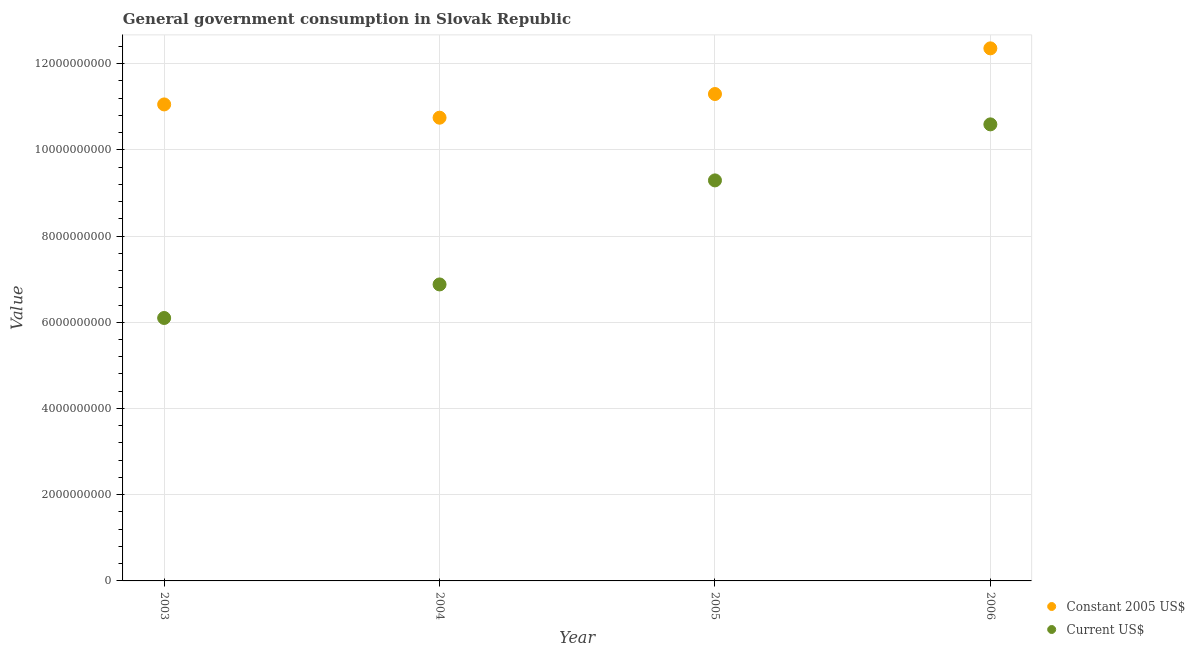Is the number of dotlines equal to the number of legend labels?
Your answer should be compact. Yes. What is the value consumed in constant 2005 us$ in 2005?
Offer a terse response. 1.13e+1. Across all years, what is the maximum value consumed in constant 2005 us$?
Give a very brief answer. 1.24e+1. Across all years, what is the minimum value consumed in current us$?
Your answer should be very brief. 6.10e+09. In which year was the value consumed in current us$ maximum?
Your answer should be very brief. 2006. What is the total value consumed in constant 2005 us$ in the graph?
Provide a succinct answer. 4.54e+1. What is the difference between the value consumed in current us$ in 2003 and that in 2006?
Provide a succinct answer. -4.49e+09. What is the difference between the value consumed in constant 2005 us$ in 2006 and the value consumed in current us$ in 2004?
Make the answer very short. 5.48e+09. What is the average value consumed in constant 2005 us$ per year?
Give a very brief answer. 1.14e+1. In the year 2005, what is the difference between the value consumed in current us$ and value consumed in constant 2005 us$?
Provide a short and direct response. -2.00e+09. What is the ratio of the value consumed in current us$ in 2004 to that in 2005?
Give a very brief answer. 0.74. Is the value consumed in current us$ in 2003 less than that in 2004?
Provide a short and direct response. Yes. Is the difference between the value consumed in current us$ in 2004 and 2005 greater than the difference between the value consumed in constant 2005 us$ in 2004 and 2005?
Your answer should be compact. No. What is the difference between the highest and the second highest value consumed in constant 2005 us$?
Offer a very short reply. 1.06e+09. What is the difference between the highest and the lowest value consumed in constant 2005 us$?
Offer a terse response. 1.61e+09. Is the value consumed in constant 2005 us$ strictly greater than the value consumed in current us$ over the years?
Offer a very short reply. Yes. Is the value consumed in constant 2005 us$ strictly less than the value consumed in current us$ over the years?
Give a very brief answer. No. How many dotlines are there?
Keep it short and to the point. 2. What is the difference between two consecutive major ticks on the Y-axis?
Give a very brief answer. 2.00e+09. Are the values on the major ticks of Y-axis written in scientific E-notation?
Provide a succinct answer. No. Does the graph contain grids?
Your answer should be very brief. Yes. Where does the legend appear in the graph?
Provide a short and direct response. Bottom right. How are the legend labels stacked?
Keep it short and to the point. Vertical. What is the title of the graph?
Ensure brevity in your answer.  General government consumption in Slovak Republic. Does "Net savings(excluding particulate emission damage)" appear as one of the legend labels in the graph?
Give a very brief answer. No. What is the label or title of the Y-axis?
Your response must be concise. Value. What is the Value of Constant 2005 US$ in 2003?
Provide a succinct answer. 1.11e+1. What is the Value in Current US$ in 2003?
Keep it short and to the point. 6.10e+09. What is the Value of Constant 2005 US$ in 2004?
Provide a succinct answer. 1.07e+1. What is the Value of Current US$ in 2004?
Provide a short and direct response. 6.88e+09. What is the Value of Constant 2005 US$ in 2005?
Your answer should be compact. 1.13e+1. What is the Value of Current US$ in 2005?
Provide a succinct answer. 9.29e+09. What is the Value of Constant 2005 US$ in 2006?
Give a very brief answer. 1.24e+1. What is the Value in Current US$ in 2006?
Provide a short and direct response. 1.06e+1. Across all years, what is the maximum Value in Constant 2005 US$?
Your answer should be compact. 1.24e+1. Across all years, what is the maximum Value in Current US$?
Provide a short and direct response. 1.06e+1. Across all years, what is the minimum Value in Constant 2005 US$?
Give a very brief answer. 1.07e+1. Across all years, what is the minimum Value of Current US$?
Offer a terse response. 6.10e+09. What is the total Value of Constant 2005 US$ in the graph?
Provide a short and direct response. 4.54e+1. What is the total Value in Current US$ in the graph?
Your answer should be very brief. 3.29e+1. What is the difference between the Value in Constant 2005 US$ in 2003 and that in 2004?
Keep it short and to the point. 3.08e+08. What is the difference between the Value of Current US$ in 2003 and that in 2004?
Offer a very short reply. -7.78e+08. What is the difference between the Value of Constant 2005 US$ in 2003 and that in 2005?
Offer a very short reply. -2.41e+08. What is the difference between the Value in Current US$ in 2003 and that in 2005?
Your answer should be very brief. -3.19e+09. What is the difference between the Value of Constant 2005 US$ in 2003 and that in 2006?
Give a very brief answer. -1.30e+09. What is the difference between the Value of Current US$ in 2003 and that in 2006?
Give a very brief answer. -4.49e+09. What is the difference between the Value in Constant 2005 US$ in 2004 and that in 2005?
Provide a succinct answer. -5.49e+08. What is the difference between the Value of Current US$ in 2004 and that in 2005?
Provide a short and direct response. -2.41e+09. What is the difference between the Value in Constant 2005 US$ in 2004 and that in 2006?
Provide a short and direct response. -1.61e+09. What is the difference between the Value of Current US$ in 2004 and that in 2006?
Ensure brevity in your answer.  -3.71e+09. What is the difference between the Value in Constant 2005 US$ in 2005 and that in 2006?
Provide a succinct answer. -1.06e+09. What is the difference between the Value of Current US$ in 2005 and that in 2006?
Offer a terse response. -1.30e+09. What is the difference between the Value of Constant 2005 US$ in 2003 and the Value of Current US$ in 2004?
Offer a very short reply. 4.18e+09. What is the difference between the Value of Constant 2005 US$ in 2003 and the Value of Current US$ in 2005?
Provide a short and direct response. 1.76e+09. What is the difference between the Value of Constant 2005 US$ in 2003 and the Value of Current US$ in 2006?
Your response must be concise. 4.63e+08. What is the difference between the Value in Constant 2005 US$ in 2004 and the Value in Current US$ in 2005?
Provide a short and direct response. 1.45e+09. What is the difference between the Value in Constant 2005 US$ in 2004 and the Value in Current US$ in 2006?
Provide a short and direct response. 1.55e+08. What is the difference between the Value of Constant 2005 US$ in 2005 and the Value of Current US$ in 2006?
Provide a short and direct response. 7.04e+08. What is the average Value in Constant 2005 US$ per year?
Your answer should be very brief. 1.14e+1. What is the average Value of Current US$ per year?
Make the answer very short. 8.21e+09. In the year 2003, what is the difference between the Value of Constant 2005 US$ and Value of Current US$?
Ensure brevity in your answer.  4.95e+09. In the year 2004, what is the difference between the Value in Constant 2005 US$ and Value in Current US$?
Offer a terse response. 3.87e+09. In the year 2005, what is the difference between the Value in Constant 2005 US$ and Value in Current US$?
Your answer should be very brief. 2.00e+09. In the year 2006, what is the difference between the Value in Constant 2005 US$ and Value in Current US$?
Give a very brief answer. 1.76e+09. What is the ratio of the Value of Constant 2005 US$ in 2003 to that in 2004?
Keep it short and to the point. 1.03. What is the ratio of the Value in Current US$ in 2003 to that in 2004?
Provide a short and direct response. 0.89. What is the ratio of the Value of Constant 2005 US$ in 2003 to that in 2005?
Your response must be concise. 0.98. What is the ratio of the Value of Current US$ in 2003 to that in 2005?
Offer a very short reply. 0.66. What is the ratio of the Value of Constant 2005 US$ in 2003 to that in 2006?
Ensure brevity in your answer.  0.89. What is the ratio of the Value in Current US$ in 2003 to that in 2006?
Offer a terse response. 0.58. What is the ratio of the Value in Constant 2005 US$ in 2004 to that in 2005?
Keep it short and to the point. 0.95. What is the ratio of the Value in Current US$ in 2004 to that in 2005?
Your answer should be very brief. 0.74. What is the ratio of the Value in Constant 2005 US$ in 2004 to that in 2006?
Ensure brevity in your answer.  0.87. What is the ratio of the Value in Current US$ in 2004 to that in 2006?
Your response must be concise. 0.65. What is the ratio of the Value of Constant 2005 US$ in 2005 to that in 2006?
Offer a terse response. 0.91. What is the ratio of the Value of Current US$ in 2005 to that in 2006?
Keep it short and to the point. 0.88. What is the difference between the highest and the second highest Value of Constant 2005 US$?
Keep it short and to the point. 1.06e+09. What is the difference between the highest and the second highest Value of Current US$?
Your answer should be compact. 1.30e+09. What is the difference between the highest and the lowest Value in Constant 2005 US$?
Your answer should be compact. 1.61e+09. What is the difference between the highest and the lowest Value of Current US$?
Provide a succinct answer. 4.49e+09. 